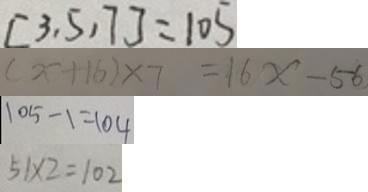Convert formula to latex. <formula><loc_0><loc_0><loc_500><loc_500>[ 3 , 5 , 7 ] = 1 0 5 
 ( x + 1 6 ) \times 7 = 1 6 x - 5 6 
 1 0 5 - 1 = 1 0 4 
 5 1 \times 2 = 1 0 2</formula> 